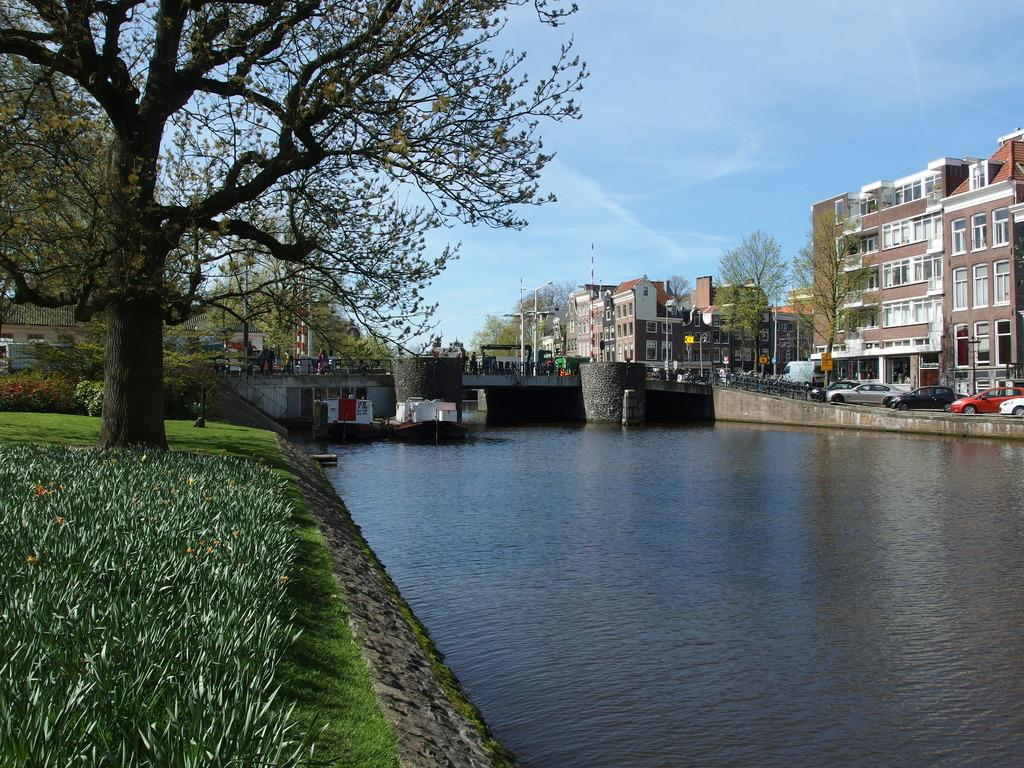What type of terrain is visible in the image? There is grass in the image. What natural element is present in the image? There is water in the image. What man-made structure can be seen in the image? There is a bridge in the image. What part of the natural environment is visible in the image? The sky is visible at the top of the image. What type of structures are present in the image? There are buildings in the image. What mode of transportation can be seen in the image? There are vehicles in the image. What type of vegetation is present in the image? There are trees and plants in the image. What utility infrastructure is present in the image? There are current poles in the image. What type of skirt is the dad wearing in the image? There is no dad or skirt present in the image. What type of roof is visible on the buildings in the image? The provided facts do not mention the type of roof on the buildings in the image. 